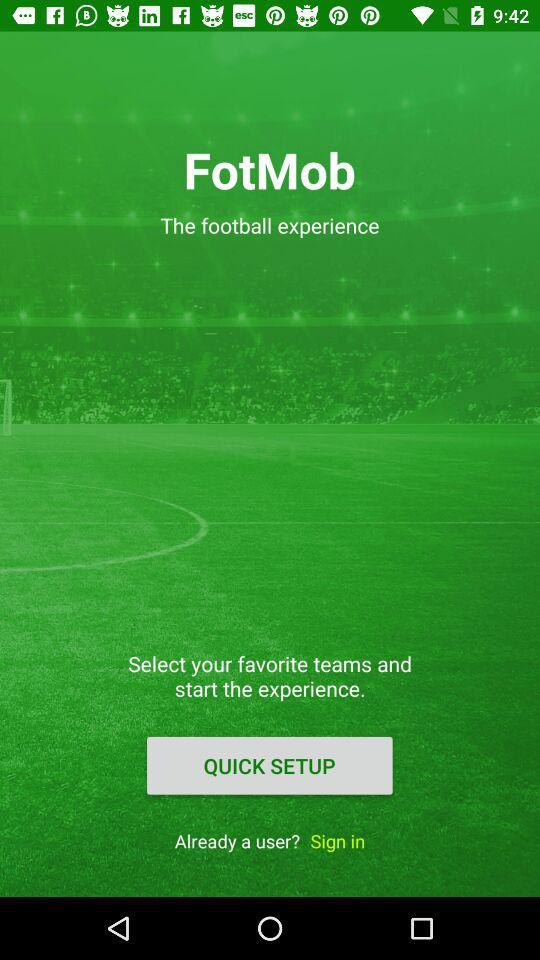What is the name of the application? The name of the application is "FotMob". 